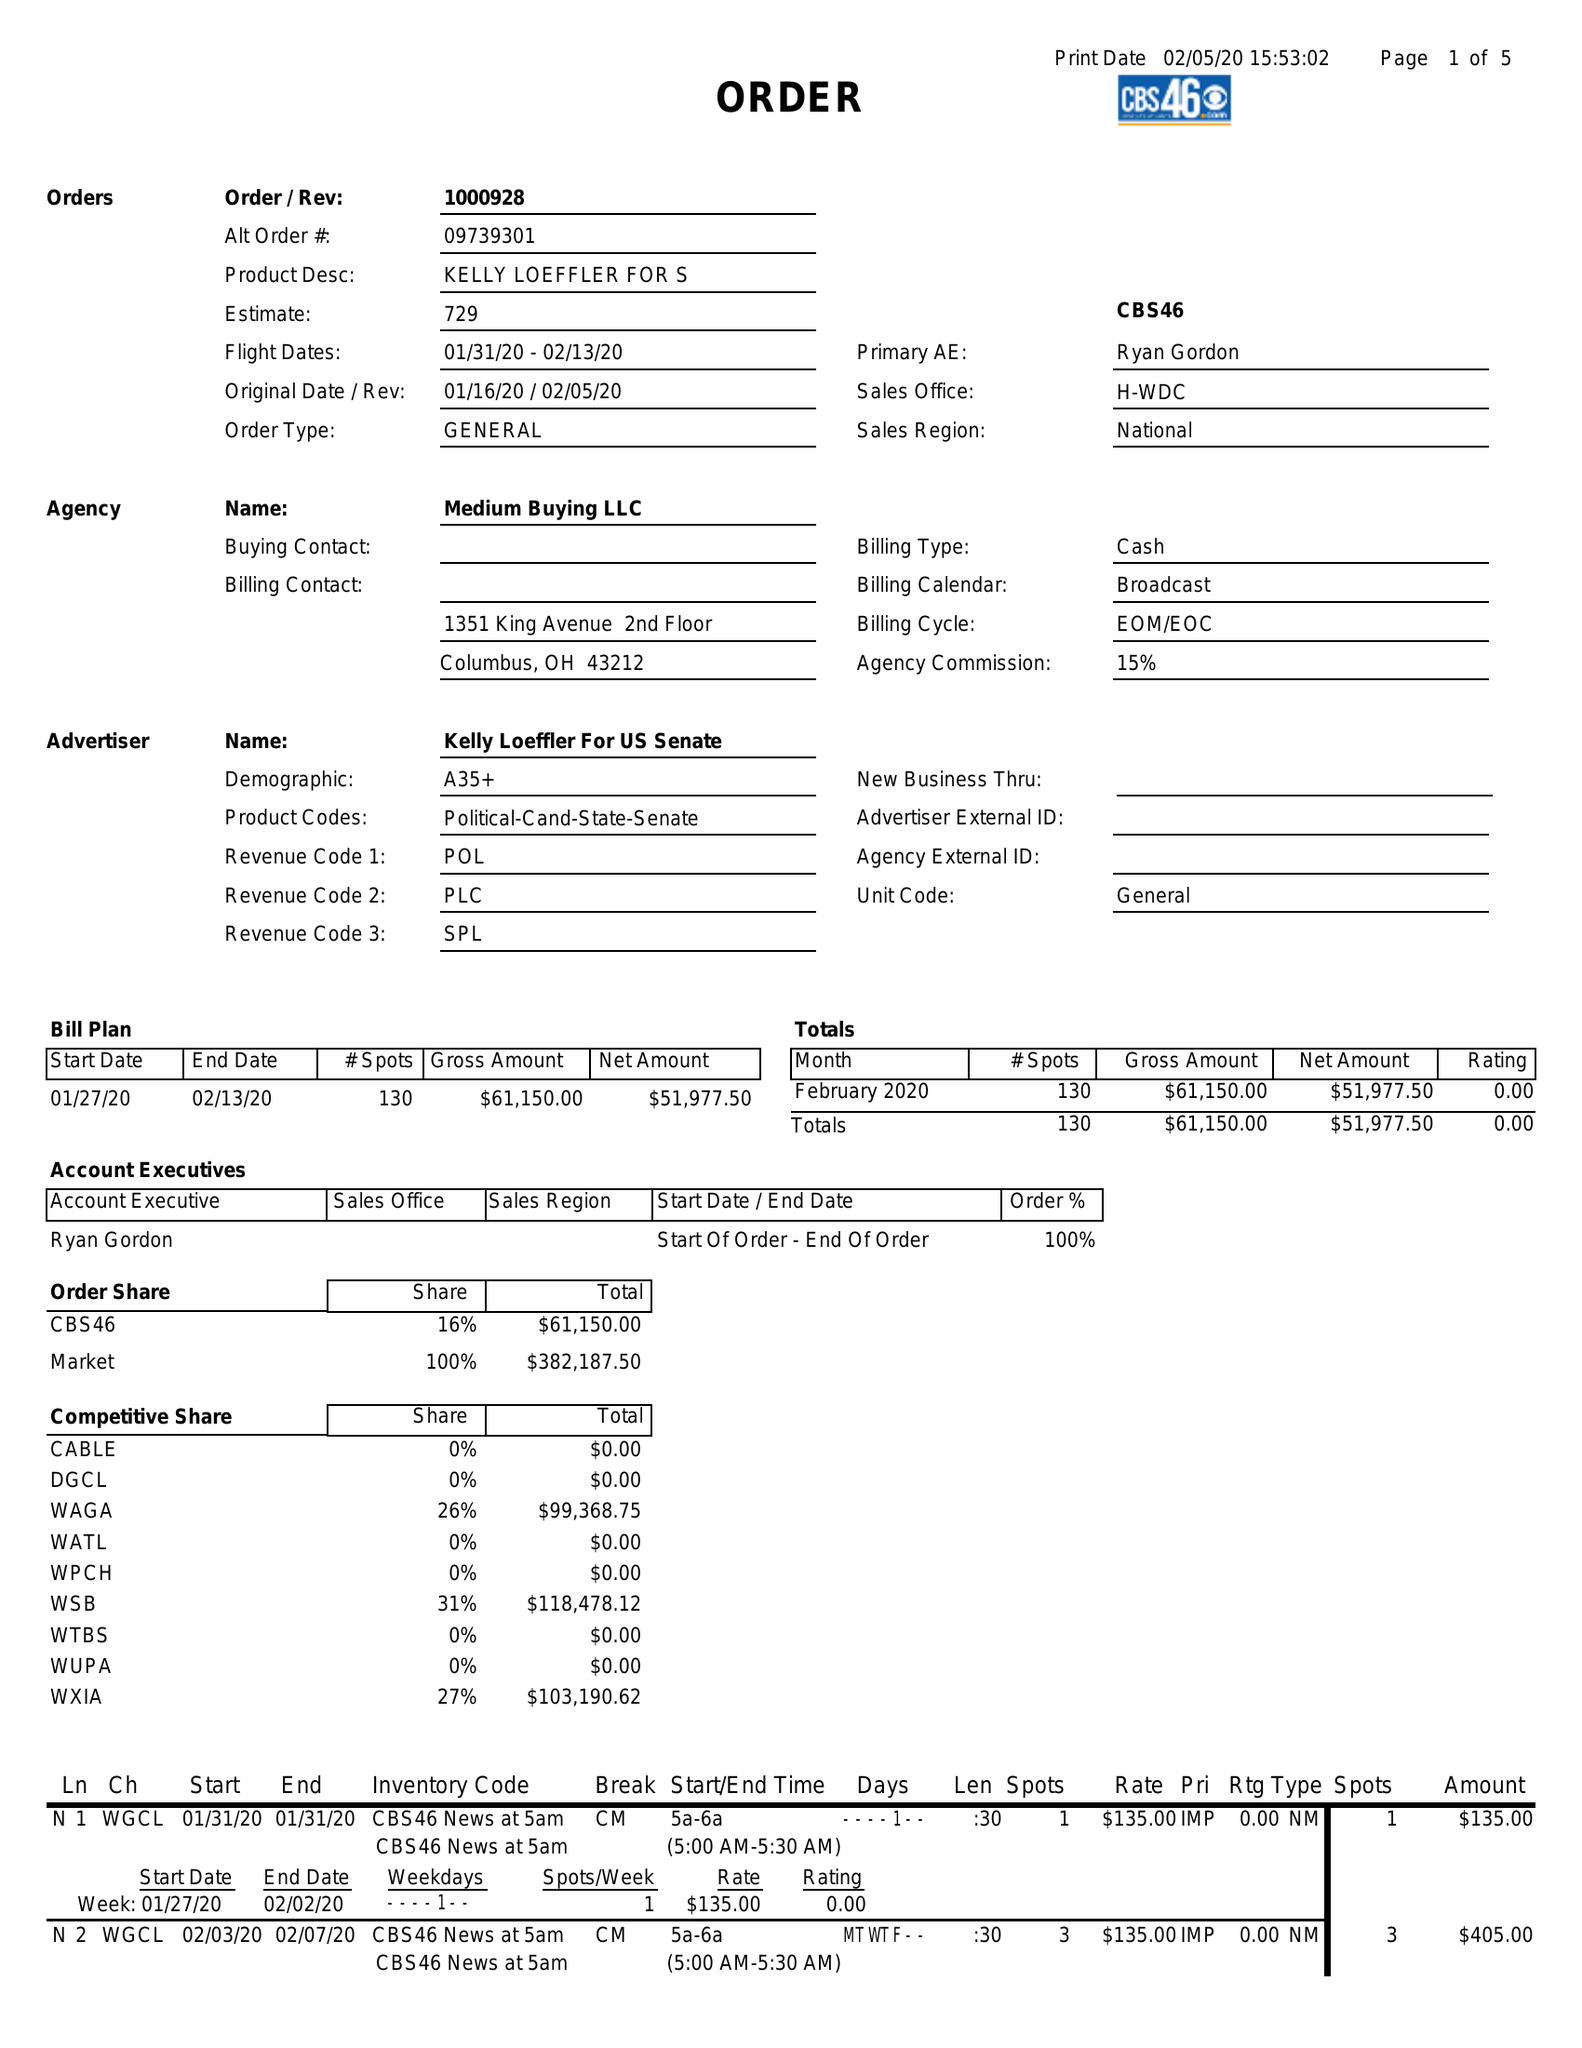What is the value for the gross_amount?
Answer the question using a single word or phrase. 61150.00 